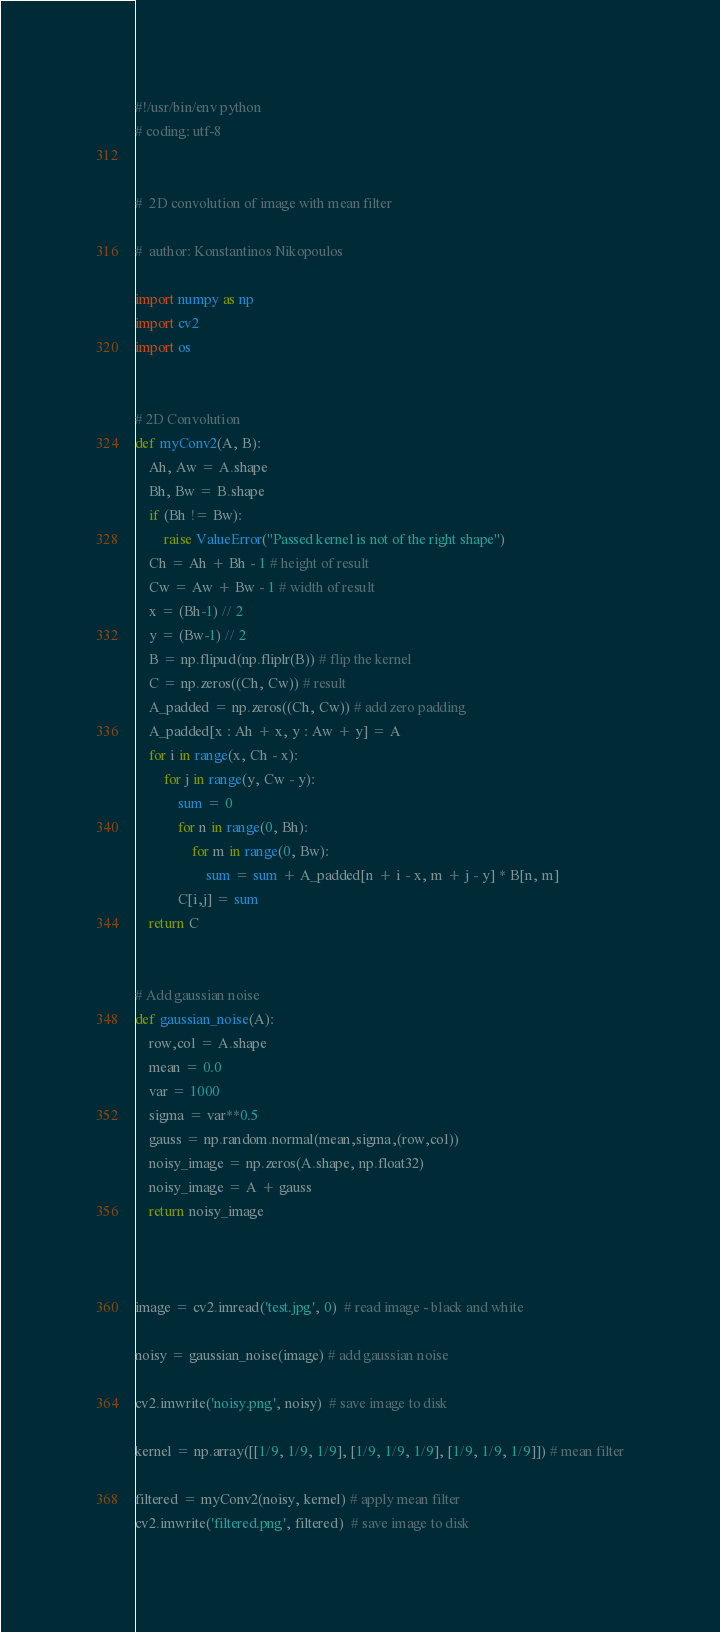<code> <loc_0><loc_0><loc_500><loc_500><_Python_>#!/usr/bin/env python
# coding: utf-8


#  2D convolution of image with mean filter

#  author: Konstantinos Nikopoulos

import numpy as np
import cv2
import os


# 2D Convolution
def myConv2(A, B):
    Ah, Aw = A.shape
    Bh, Bw = B.shape
    if (Bh != Bw):
        raise ValueError("Passed kernel is not of the right shape")
    Ch = Ah + Bh - 1 # height of result
    Cw = Aw + Bw - 1 # width of result
    x = (Bh-1) // 2
    y = (Bw-1) // 2
    B = np.flipud(np.fliplr(B)) # flip the kernel
    C = np.zeros((Ch, Cw)) # result 
    A_padded = np.zeros((Ch, Cw)) # add zero padding 
    A_padded[x : Ah + x, y : Aw + y] = A
    for i in range(x, Ch - x): 
        for j in range(y, Cw - y):
            sum = 0
            for n in range(0, Bh):
                for m in range(0, Bw):
                    sum = sum + A_padded[n + i - x, m + j - y] * B[n, m]
            C[i,j] = sum 
    return C


# Add gaussian noise
def gaussian_noise(A):
    row,col = A.shape
    mean = 0.0
    var = 1000
    sigma = var**0.5
    gauss = np.random.normal(mean,sigma,(row,col))
    noisy_image = np.zeros(A.shape, np.float32)
    noisy_image = A + gauss
    return noisy_image
    


image = cv2.imread('test.jpg', 0)  # read image - black and white

noisy = gaussian_noise(image) # add gaussian noise

cv2.imwrite('noisy.png', noisy)  # save image to disk

kernel = np.array([[1/9, 1/9, 1/9], [1/9, 1/9, 1/9], [1/9, 1/9, 1/9]]) # mean filter

filtered = myConv2(noisy, kernel) # apply mean filter
cv2.imwrite('filtered.png', filtered)  # save image to disk






</code> 